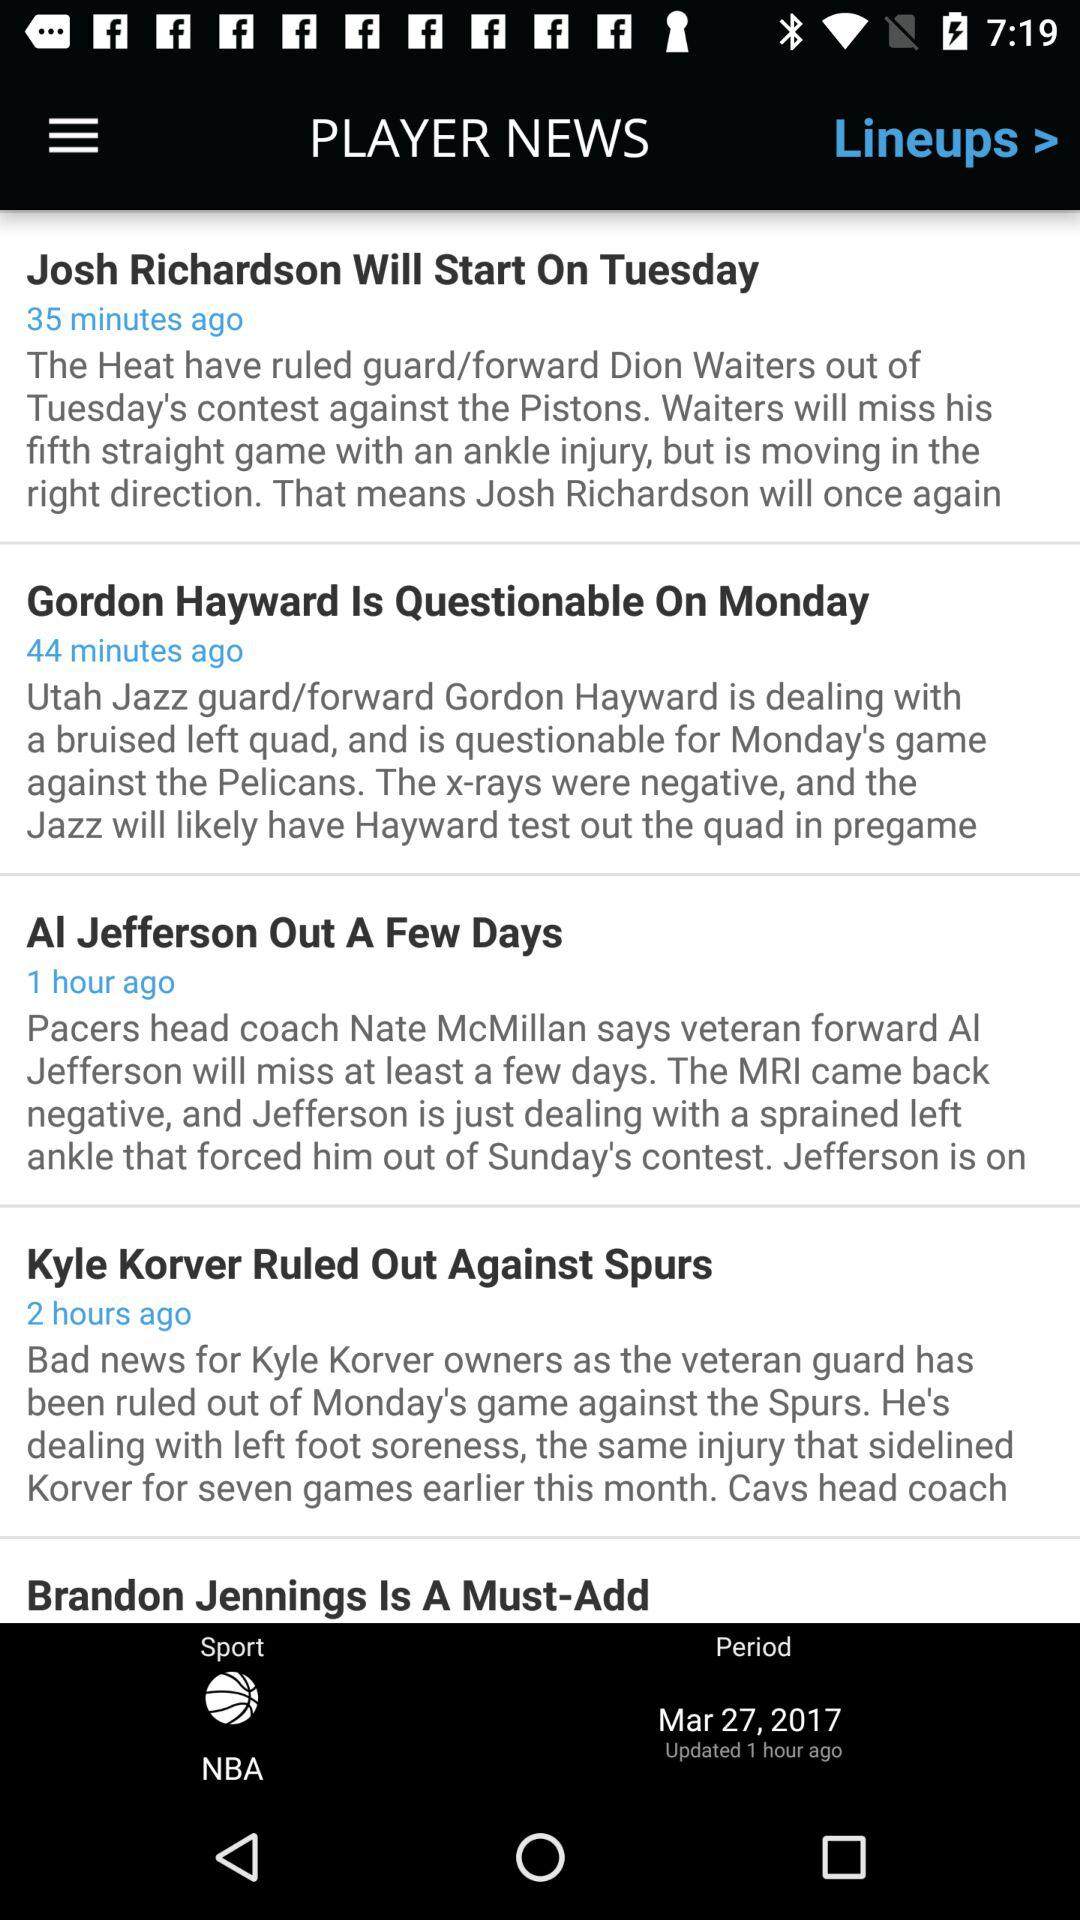What is the sport name? The sport is the NBA. 